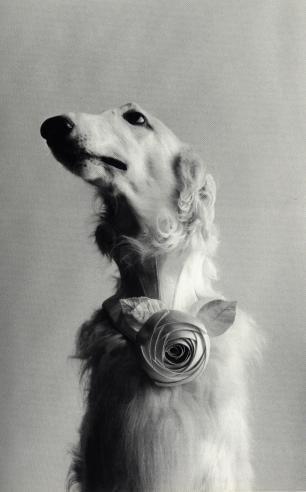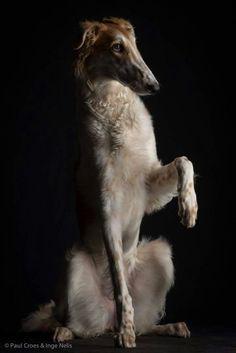The first image is the image on the left, the second image is the image on the right. Analyze the images presented: Is the assertion "A dog is in a chair." valid? Answer yes or no. No. The first image is the image on the left, the second image is the image on the right. Considering the images on both sides, is "The right image shows a hound posed on an upholstered chair, with one front paw propped on the side of the chair." valid? Answer yes or no. No. 